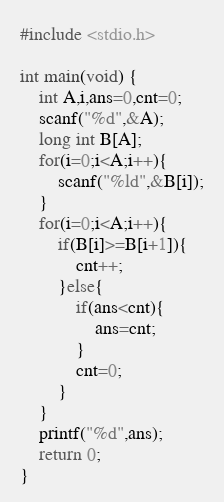Convert code to text. <code><loc_0><loc_0><loc_500><loc_500><_C_>#include <stdio.h>

int main(void) {
	int A,i,ans=0,cnt=0;
	scanf("%d",&A);
	long int B[A];
	for(i=0;i<A;i++){
		scanf("%ld",&B[i]);
	}
	for(i=0;i<A;i++){
		if(B[i]>=B[i+1]){
			cnt++;
		}else{
			if(ans<cnt){
				ans=cnt;
			}
			cnt=0;
		}
	}
	printf("%d",ans);
	return 0;
}</code> 